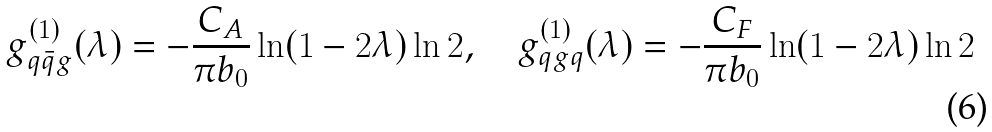Convert formula to latex. <formula><loc_0><loc_0><loc_500><loc_500>g ^ { ( 1 ) } _ { q \bar { q } g } ( \lambda ) = - \frac { C _ { A } } { \pi b _ { 0 } } \ln ( 1 - 2 \lambda ) \ln 2 , \quad g ^ { ( 1 ) } _ { q g q } ( \lambda ) = - \frac { C _ { F } } { \pi b _ { 0 } } \ln ( 1 - 2 \lambda ) \ln 2</formula> 